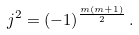Convert formula to latex. <formula><loc_0><loc_0><loc_500><loc_500>j ^ { 2 } = ( - 1 ) ^ { \frac { m ( m + 1 ) } { 2 } } \, .</formula> 